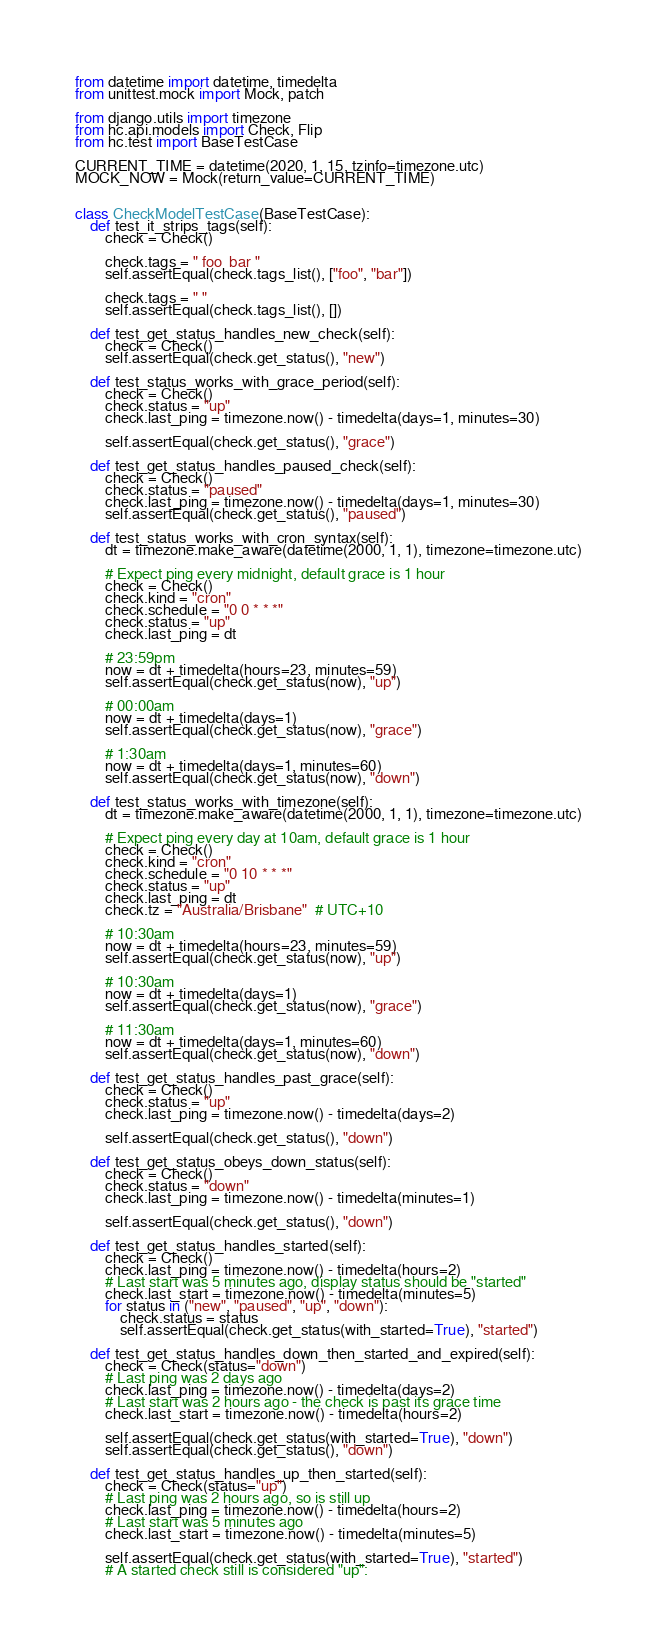<code> <loc_0><loc_0><loc_500><loc_500><_Python_>from datetime import datetime, timedelta
from unittest.mock import Mock, patch

from django.utils import timezone
from hc.api.models import Check, Flip
from hc.test import BaseTestCase

CURRENT_TIME = datetime(2020, 1, 15, tzinfo=timezone.utc)
MOCK_NOW = Mock(return_value=CURRENT_TIME)


class CheckModelTestCase(BaseTestCase):
    def test_it_strips_tags(self):
        check = Check()

        check.tags = " foo  bar "
        self.assertEqual(check.tags_list(), ["foo", "bar"])

        check.tags = " "
        self.assertEqual(check.tags_list(), [])

    def test_get_status_handles_new_check(self):
        check = Check()
        self.assertEqual(check.get_status(), "new")

    def test_status_works_with_grace_period(self):
        check = Check()
        check.status = "up"
        check.last_ping = timezone.now() - timedelta(days=1, minutes=30)

        self.assertEqual(check.get_status(), "grace")

    def test_get_status_handles_paused_check(self):
        check = Check()
        check.status = "paused"
        check.last_ping = timezone.now() - timedelta(days=1, minutes=30)
        self.assertEqual(check.get_status(), "paused")

    def test_status_works_with_cron_syntax(self):
        dt = timezone.make_aware(datetime(2000, 1, 1), timezone=timezone.utc)

        # Expect ping every midnight, default grace is 1 hour
        check = Check()
        check.kind = "cron"
        check.schedule = "0 0 * * *"
        check.status = "up"
        check.last_ping = dt

        # 23:59pm
        now = dt + timedelta(hours=23, minutes=59)
        self.assertEqual(check.get_status(now), "up")

        # 00:00am
        now = dt + timedelta(days=1)
        self.assertEqual(check.get_status(now), "grace")

        # 1:30am
        now = dt + timedelta(days=1, minutes=60)
        self.assertEqual(check.get_status(now), "down")

    def test_status_works_with_timezone(self):
        dt = timezone.make_aware(datetime(2000, 1, 1), timezone=timezone.utc)

        # Expect ping every day at 10am, default grace is 1 hour
        check = Check()
        check.kind = "cron"
        check.schedule = "0 10 * * *"
        check.status = "up"
        check.last_ping = dt
        check.tz = "Australia/Brisbane"  # UTC+10

        # 10:30am
        now = dt + timedelta(hours=23, minutes=59)
        self.assertEqual(check.get_status(now), "up")

        # 10:30am
        now = dt + timedelta(days=1)
        self.assertEqual(check.get_status(now), "grace")

        # 11:30am
        now = dt + timedelta(days=1, minutes=60)
        self.assertEqual(check.get_status(now), "down")

    def test_get_status_handles_past_grace(self):
        check = Check()
        check.status = "up"
        check.last_ping = timezone.now() - timedelta(days=2)

        self.assertEqual(check.get_status(), "down")

    def test_get_status_obeys_down_status(self):
        check = Check()
        check.status = "down"
        check.last_ping = timezone.now() - timedelta(minutes=1)

        self.assertEqual(check.get_status(), "down")

    def test_get_status_handles_started(self):
        check = Check()
        check.last_ping = timezone.now() - timedelta(hours=2)
        # Last start was 5 minutes ago, display status should be "started"
        check.last_start = timezone.now() - timedelta(minutes=5)
        for status in ("new", "paused", "up", "down"):
            check.status = status
            self.assertEqual(check.get_status(with_started=True), "started")

    def test_get_status_handles_down_then_started_and_expired(self):
        check = Check(status="down")
        # Last ping was 2 days ago
        check.last_ping = timezone.now() - timedelta(days=2)
        # Last start was 2 hours ago - the check is past its grace time
        check.last_start = timezone.now() - timedelta(hours=2)

        self.assertEqual(check.get_status(with_started=True), "down")
        self.assertEqual(check.get_status(), "down")

    def test_get_status_handles_up_then_started(self):
        check = Check(status="up")
        # Last ping was 2 hours ago, so is still up
        check.last_ping = timezone.now() - timedelta(hours=2)
        # Last start was 5 minutes ago
        check.last_start = timezone.now() - timedelta(minutes=5)

        self.assertEqual(check.get_status(with_started=True), "started")
        # A started check still is considered "up":</code> 